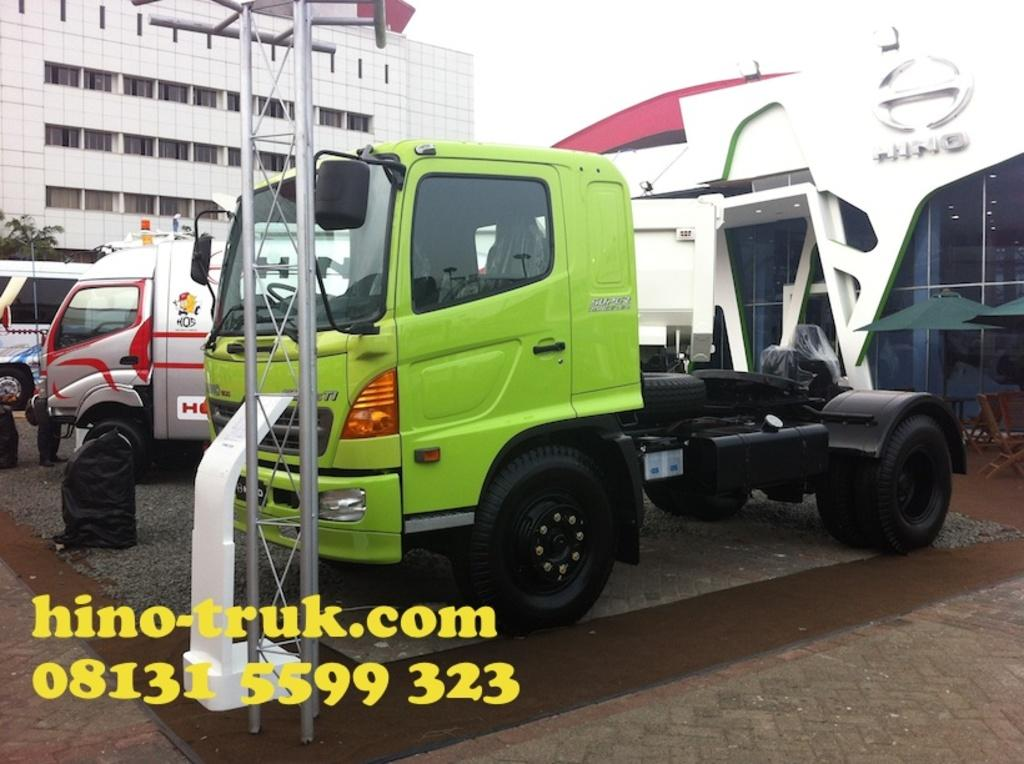What is the main subject in the center of the image? There is a truck in the center of the image. What can be seen in the background of the image? There is a building, trucks, chairs, and the sky visible in the background of the image. What type of glue is being used to hold the oranges together in the image? There are no oranges or glue present in the image. How many trains can be seen in the image? There are no trains visible in the image. 